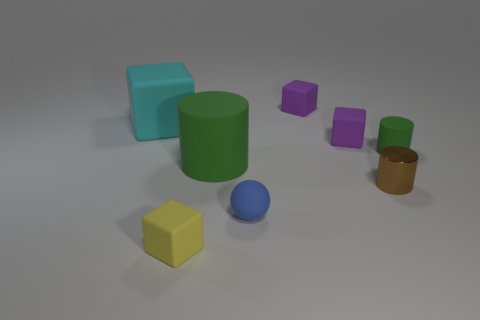Subtract all big cubes. How many cubes are left? 3 Subtract all blue balls. How many green cylinders are left? 2 Subtract all cyan blocks. How many blocks are left? 3 Subtract 2 blocks. How many blocks are left? 2 Add 2 small gray metallic spheres. How many objects exist? 10 Subtract all brown blocks. Subtract all gray cylinders. How many blocks are left? 4 Subtract all balls. How many objects are left? 7 Add 4 metal cylinders. How many metal cylinders are left? 5 Add 3 large gray metallic blocks. How many large gray metallic blocks exist? 3 Subtract 0 red blocks. How many objects are left? 8 